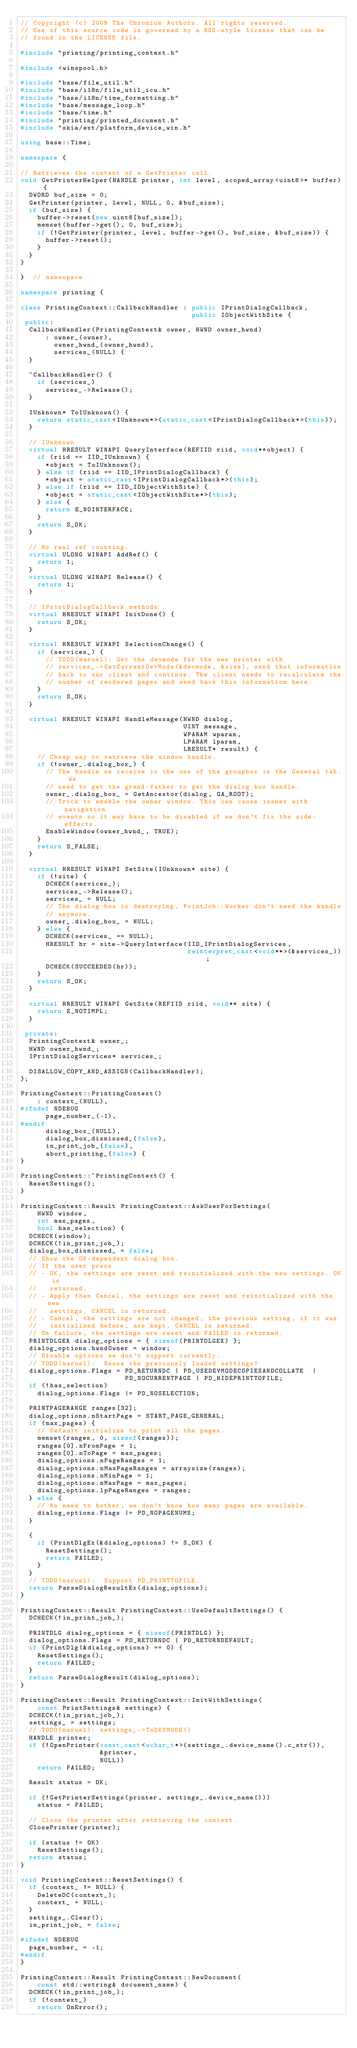Convert code to text. <code><loc_0><loc_0><loc_500><loc_500><_C++_>// Copyright (c) 2009 The Chromium Authors. All rights reserved.
// Use of this source code is governed by a BSD-style license that can be
// found in the LICENSE file.

#include "printing/printing_context.h"

#include <winspool.h>

#include "base/file_util.h"
#include "base/i18n/file_util_icu.h"
#include "base/i18n/time_formatting.h"
#include "base/message_loop.h"
#include "base/time.h"
#include "printing/printed_document.h"
#include "skia/ext/platform_device_win.h"

using base::Time;

namespace {

// Retrieves the content of a GetPrinter call.
void GetPrinterHelper(HANDLE printer, int level, scoped_array<uint8>* buffer) {
  DWORD buf_size = 0;
  GetPrinter(printer, level, NULL, 0, &buf_size);
  if (buf_size) {
    buffer->reset(new uint8[buf_size]);
    memset(buffer->get(), 0, buf_size);
    if (!GetPrinter(printer, level, buffer->get(), buf_size, &buf_size)) {
      buffer->reset();
    }
  }
}

}  // namespace

namespace printing {

class PrintingContext::CallbackHandler : public IPrintDialogCallback,
                                         public IObjectWithSite {
 public:
  CallbackHandler(PrintingContext& owner, HWND owner_hwnd)
      : owner_(owner),
        owner_hwnd_(owner_hwnd),
        services_(NULL) {
  }

  ~CallbackHandler() {
    if (services_)
      services_->Release();
  }

  IUnknown* ToIUnknown() {
    return static_cast<IUnknown*>(static_cast<IPrintDialogCallback*>(this));
  }

  // IUnknown
  virtual HRESULT WINAPI QueryInterface(REFIID riid, void**object) {
    if (riid == IID_IUnknown) {
      *object = ToIUnknown();
    } else if (riid == IID_IPrintDialogCallback) {
      *object = static_cast<IPrintDialogCallback*>(this);
    } else if (riid == IID_IObjectWithSite) {
      *object = static_cast<IObjectWithSite*>(this);
    } else {
      return E_NOINTERFACE;
    }
    return S_OK;
  }

  // No real ref counting.
  virtual ULONG WINAPI AddRef() {
    return 1;
  }
  virtual ULONG WINAPI Release() {
    return 1;
  }

  // IPrintDialogCallback methods
  virtual HRESULT WINAPI InitDone() {
    return S_OK;
  }

  virtual HRESULT WINAPI SelectionChange() {
    if (services_) {
      // TODO(maruel): Get the devmode for the new printer with
      // services_->GetCurrentDevMode(&devmode, &size), send that information
      // back to our client and continue. The client needs to recalculate the
      // number of rendered pages and send back this information here.
    }
    return S_OK;
  }

  virtual HRESULT WINAPI HandleMessage(HWND dialog,
                                       UINT message,
                                       WPARAM wparam,
                                       LPARAM lparam,
                                       LRESULT* result) {
    // Cheap way to retrieve the window handle.
    if (!owner_.dialog_box_) {
      // The handle we receive is the one of the groupbox in the General tab. We
      // need to get the grand-father to get the dialog box handle.
      owner_.dialog_box_ = GetAncestor(dialog, GA_ROOT);
      // Trick to enable the owner window. This can cause issues with navigation
      // events so it may have to be disabled if we don't fix the side-effects.
      EnableWindow(owner_hwnd_, TRUE);
    }
    return S_FALSE;
  }

  virtual HRESULT WINAPI SetSite(IUnknown* site) {
    if (!site) {
      DCHECK(services_);
      services_->Release();
      services_ = NULL;
      // The dialog box is destroying, PrintJob::Worker don't need the handle
      // anymore.
      owner_.dialog_box_ = NULL;
    } else {
      DCHECK(services_ == NULL);
      HRESULT hr = site->QueryInterface(IID_IPrintDialogServices,
                                        reinterpret_cast<void**>(&services_));
      DCHECK(SUCCEEDED(hr));
    }
    return S_OK;
  }

  virtual HRESULT WINAPI GetSite(REFIID riid, void** site) {
    return E_NOTIMPL;
  }

 private:
  PrintingContext& owner_;
  HWND owner_hwnd_;
  IPrintDialogServices* services_;

  DISALLOW_COPY_AND_ASSIGN(CallbackHandler);
};

PrintingContext::PrintingContext()
    : context_(NULL),
#ifndef NDEBUG
      page_number_(-1),
#endif
      dialog_box_(NULL),
      dialog_box_dismissed_(false),
      in_print_job_(false),
      abort_printing_(false) {
}

PrintingContext::~PrintingContext() {
  ResetSettings();
}

PrintingContext::Result PrintingContext::AskUserForSettings(
    HWND window,
    int max_pages,
    bool has_selection) {
  DCHECK(window);
  DCHECK(!in_print_job_);
  dialog_box_dismissed_ = false;
  // Show the OS-dependent dialog box.
  // If the user press
  // - OK, the settings are reset and reinitialized with the new settings. OK is
  //   returned.
  // - Apply then Cancel, the settings are reset and reinitialized with the new
  //   settings. CANCEL is returned.
  // - Cancel, the settings are not changed, the previous setting, if it was
  //   initialized before, are kept. CANCEL is returned.
  // On failure, the settings are reset and FAILED is returned.
  PRINTDLGEX dialog_options = { sizeof(PRINTDLGEX) };
  dialog_options.hwndOwner = window;
  // Disable options we don't support currently.
  // TODO(maruel):  Reuse the previously loaded settings!
  dialog_options.Flags = PD_RETURNDC | PD_USEDEVMODECOPIESANDCOLLATE  |
                         PD_NOCURRENTPAGE | PD_HIDEPRINTTOFILE;
  if (!has_selection)
    dialog_options.Flags |= PD_NOSELECTION;

  PRINTPAGERANGE ranges[32];
  dialog_options.nStartPage = START_PAGE_GENERAL;
  if (max_pages) {
    // Default initialize to print all the pages.
    memset(ranges, 0, sizeof(ranges));
    ranges[0].nFromPage = 1;
    ranges[0].nToPage = max_pages;
    dialog_options.nPageRanges = 1;
    dialog_options.nMaxPageRanges = arraysize(ranges);
    dialog_options.nMinPage = 1;
    dialog_options.nMaxPage = max_pages;
    dialog_options.lpPageRanges = ranges;
  } else {
    // No need to bother, we don't know how many pages are available.
    dialog_options.Flags |= PD_NOPAGENUMS;
  }

  {
    if (PrintDlgEx(&dialog_options) != S_OK) {
      ResetSettings();
      return FAILED;
    }
  }
  // TODO(maruel):  Support PD_PRINTTOFILE.
  return ParseDialogResultEx(dialog_options);
}

PrintingContext::Result PrintingContext::UseDefaultSettings() {
  DCHECK(!in_print_job_);

  PRINTDLG dialog_options = { sizeof(PRINTDLG) };
  dialog_options.Flags = PD_RETURNDC | PD_RETURNDEFAULT;
  if (PrintDlg(&dialog_options) == 0) {
    ResetSettings();
    return FAILED;
  }
  return ParseDialogResult(dialog_options);
}

PrintingContext::Result PrintingContext::InitWithSettings(
    const PrintSettings& settings) {
  DCHECK(!in_print_job_);
  settings_ = settings;
  // TODO(maruel): settings_->ToDEVMODE()
  HANDLE printer;
  if (!OpenPrinter(const_cast<wchar_t*>(settings_.device_name().c_str()),
                   &printer,
                   NULL))
    return FAILED;

  Result status = OK;

  if (!GetPrinterSettings(printer, settings_.device_name()))
    status = FAILED;

  // Close the printer after retrieving the context.
  ClosePrinter(printer);

  if (status != OK)
    ResetSettings();
  return status;
}

void PrintingContext::ResetSettings() {
  if (context_ != NULL) {
    DeleteDC(context_);
    context_ = NULL;
  }
  settings_.Clear();
  in_print_job_ = false;

#ifndef NDEBUG
  page_number_ = -1;
#endif
}

PrintingContext::Result PrintingContext::NewDocument(
    const std::wstring& document_name) {
  DCHECK(!in_print_job_);
  if (!context_)
    return OnError();
</code> 